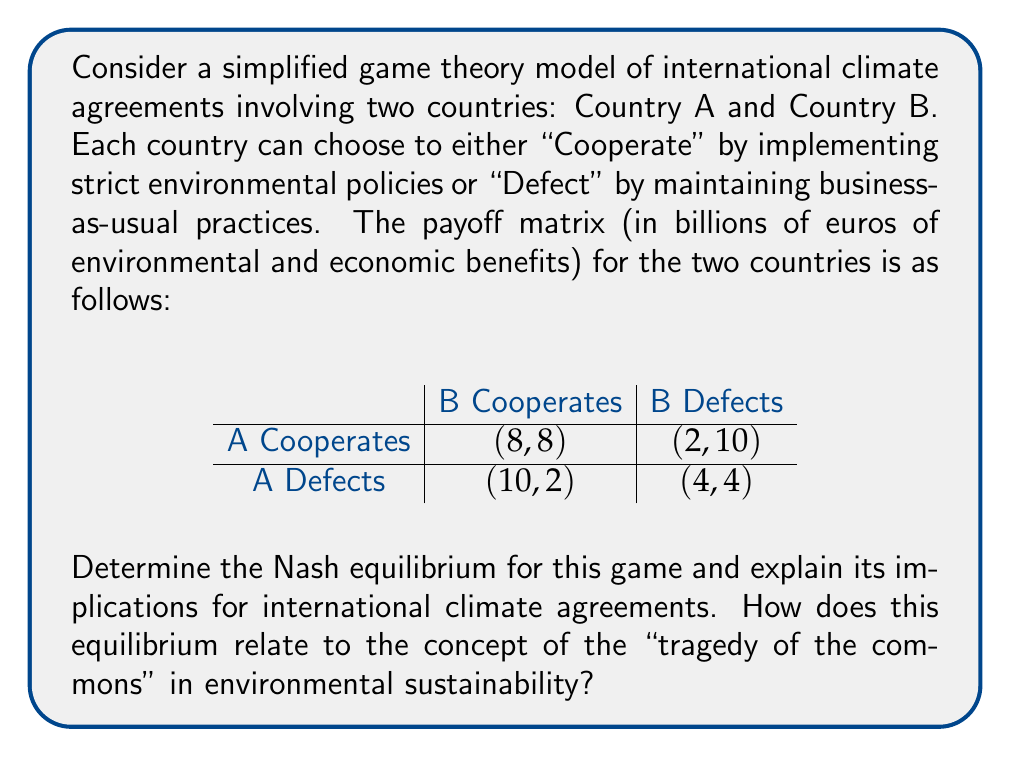What is the answer to this math problem? To solve this problem, we need to analyze the payoff matrix and determine the Nash equilibrium. A Nash equilibrium is a situation where no player can unilaterally improve their outcome by changing their strategy.

Step 1: Analyze each country's best response to the other's strategies.

For Country A:
- If B Cooperates: A's best response is to Defect (10 > 8)
- If B Defects: A's best response is to Defect (4 > 2)

For Country B:
- If A Cooperates: B's best response is to Defect (10 > 8)
- If A Defects: B's best response is to Defect (4 > 2)

Step 2: Identify the Nash equilibrium.

The Nash equilibrium occurs when both countries choose their best response to the other's strategy. In this case, regardless of what the other country does, each country's best response is to Defect. Therefore, the Nash equilibrium is (Defect, Defect) with a payoff of (4, 4).

Step 3: Analyze the implications.

This Nash equilibrium demonstrates the challenge of international climate agreements. Despite the fact that both countries would be better off if they both cooperated (payoff of 8, 8), the individual incentive to defect leads to a suboptimal outcome for both parties.

This situation relates directly to the "tragedy of the commons" in environmental sustainability. The tragedy of the commons describes a situation where individuals acting in their own self-interest ultimately deplete a shared resource, even when it's clear that it's not in anyone's long-term interest for this to happen.

In this case, the "common resource" is the global environment. Each country has a short-term incentive to defect (continue polluting) to gain economic advantages. However, if all countries follow this strategy, it leads to severe environmental degradation, which ultimately harms everyone.

This model highlights why international cooperation on climate change is challenging and why binding agreements with enforcement mechanisms are often necessary to overcome the inherent incentives to defect.

From the perspective of an economist focused on environmental sustainability, this model underscores the limitations of traditional economic metrics like GDP in capturing the true costs and benefits of environmental policies. The Nash equilibrium in this game leads to lower overall welfare (8 < 16) compared to mutual cooperation, yet might lead to higher short-term GDP growth. This illustrates why alternative measures that account for environmental externalities and long-term sustainability are crucial for informed policy-making.
Answer: The Nash equilibrium for this game is (Defect, Defect) with a payoff of (4, 4). This equilibrium illustrates the challenges in achieving international cooperation on climate change and relates to the "tragedy of the commons" in environmental sustainability. It demonstrates why traditional economic metrics like GDP may be insufficient for addressing global environmental challenges. 